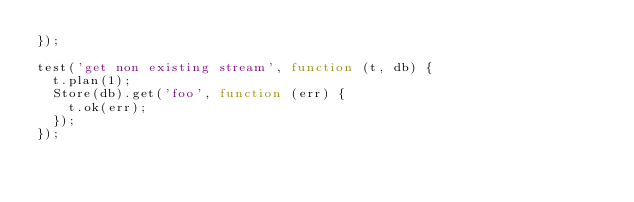Convert code to text. <code><loc_0><loc_0><loc_500><loc_500><_JavaScript_>});

test('get non existing stream', function (t, db) {
  t.plan(1);
  Store(db).get('foo', function (err) {
    t.ok(err);
  });
});
</code> 